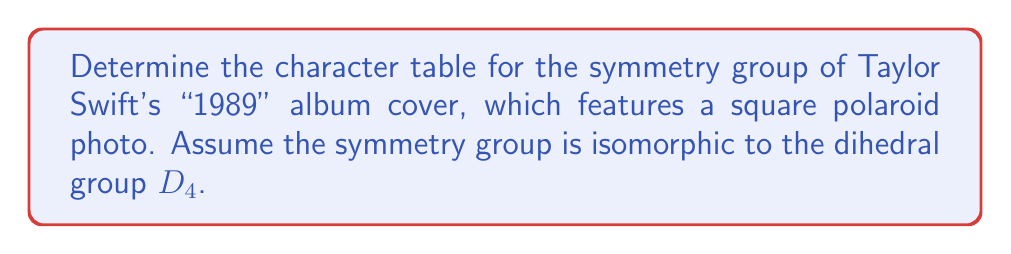Solve this math problem. Let's approach this step-by-step:

1) The dihedral group $D_4$ has 8 elements: rotations by 0°, 90°, 180°, 270°, and four reflections (horizontal, vertical, and two diagonal).

2) $D_4$ has 5 conjugacy classes:
   - $\{e\}$ (identity)
   - $\{r^2\}$ (180° rotation)
   - $\{r, r^3\}$ (90° and 270° rotations)
   - $\{s, sr^2\}$ (horizontal and vertical reflections)
   - $\{sr, sr^3\}$ (diagonal reflections)

3) $D_4$ has 5 irreducible representations, corresponding to these conjugacy classes.

4) We know that for $D_4$:
   - There are four 1-dimensional representations: the trivial representation and three others.
   - There is one 2-dimensional representation.

5) Let's label the irreducible representations as $\chi_1$ (trivial), $\chi_2$, $\chi_3$, $\chi_4$ (1-dimensional), and $\chi_5$ (2-dimensional).

6) For the trivial representation $\chi_1$, all characters are 1.

7) For $\chi_2$:
   - $\chi_2(r) = \chi_2(r^3) = -1$ (rotations change sign)
   - $\chi_2(s) = \chi_2(sr^2) = 1$ (reflections preserve sign)
   - $\chi_2(sr) = \chi_2(sr^3) = -1$ (diagonal reflections change sign)

8) For $\chi_3$:
   - $\chi_3(r) = \chi_3(r^3) = 1$
   - $\chi_3(s) = \chi_3(sr^2) = -1$
   - $\chi_3(sr) = \chi_3(sr^3) = 1$

9) For $\chi_4$:
   - $\chi_4(r) = \chi_4(r^3) = -1$
   - $\chi_4(s) = \chi_4(sr^2) = -1$
   - $\chi_4(sr) = \chi_4(sr^3) = 1$

10) For the 2-dimensional representation $\chi_5$:
    - $\chi_5(e) = 2$
    - $\chi_5(r^2) = -2$
    - $\chi_5(r) = \chi_5(r^3) = 0$
    - $\chi_5(s) = \chi_5(sr^2) = 0$
    - $\chi_5(sr) = \chi_5(sr^3) = 0$

11) Combining these, we can construct the character table:

$$
\begin{array}{c|ccccc}
D_4 & \{e\} & \{r^2\} & \{r,r^3\} & \{s,sr^2\} & \{sr,sr^3\} \\
\hline
\chi_1 & 1 & 1 & 1 & 1 & 1 \\
\chi_2 & 1 & 1 & -1 & 1 & -1 \\
\chi_3 & 1 & 1 & 1 & -1 & 1 \\
\chi_4 & 1 & 1 & -1 & -1 & 1 \\
\chi_5 & 2 & -2 & 0 & 0 & 0
\end{array}
$$

This character table fully describes the symmetry group of the square album cover.
Answer: $$
\begin{array}{c|ccccc}
D_4 & \{e\} & \{r^2\} & \{r,r^3\} & \{s,sr^2\} & \{sr,sr^3\} \\
\hline
\chi_1 & 1 & 1 & 1 & 1 & 1 \\
\chi_2 & 1 & 1 & -1 & 1 & -1 \\
\chi_3 & 1 & 1 & 1 & -1 & 1 \\
\chi_4 & 1 & 1 & -1 & -1 & 1 \\
\chi_5 & 2 & -2 & 0 & 0 & 0
\end{array}
$$ 